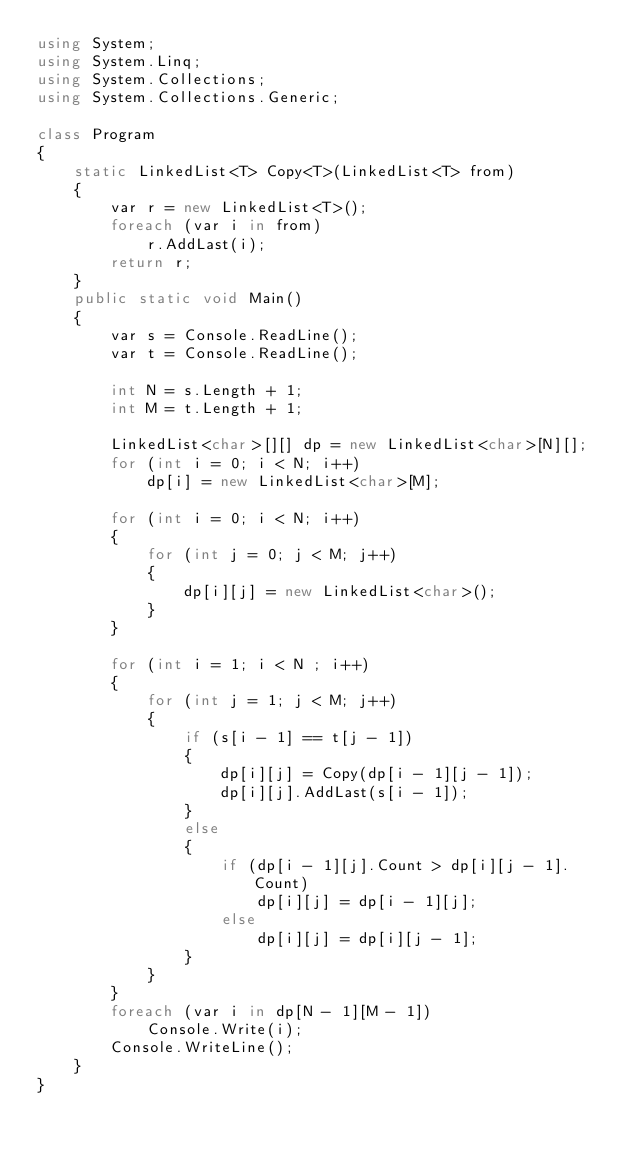Convert code to text. <code><loc_0><loc_0><loc_500><loc_500><_C#_>using System;
using System.Linq;
using System.Collections;
using System.Collections.Generic;

class Program
{
    static LinkedList<T> Copy<T>(LinkedList<T> from)
    {
        var r = new LinkedList<T>();
        foreach (var i in from)
            r.AddLast(i);
        return r;
    }
    public static void Main()
    {
        var s = Console.ReadLine();
        var t = Console.ReadLine();

        int N = s.Length + 1;
        int M = t.Length + 1;

        LinkedList<char>[][] dp = new LinkedList<char>[N][];
        for (int i = 0; i < N; i++)
            dp[i] = new LinkedList<char>[M];

        for (int i = 0; i < N; i++)
        {
            for (int j = 0; j < M; j++)
            {
                dp[i][j] = new LinkedList<char>();
            }
        }

        for (int i = 1; i < N ; i++)
        {
            for (int j = 1; j < M; j++)
            {
                if (s[i - 1] == t[j - 1])
                {
                    dp[i][j] = Copy(dp[i - 1][j - 1]);
                    dp[i][j].AddLast(s[i - 1]);
                }
                else
                {
                    if (dp[i - 1][j].Count > dp[i][j - 1].Count)
                        dp[i][j] = dp[i - 1][j];
                    else
                        dp[i][j] = dp[i][j - 1];
                }
            }
        }
        foreach (var i in dp[N - 1][M - 1])
            Console.Write(i);
        Console.WriteLine();
    }
}</code> 